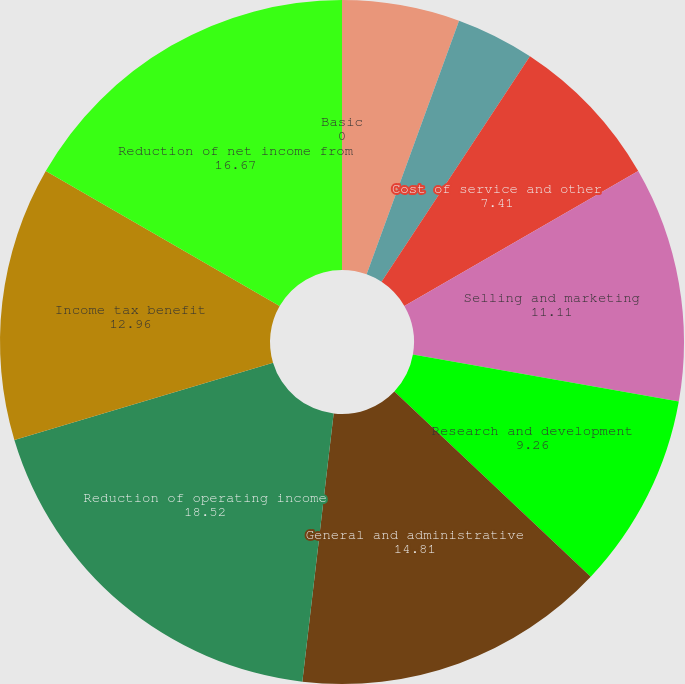Convert chart. <chart><loc_0><loc_0><loc_500><loc_500><pie_chart><fcel>(In thousands except per share<fcel>Cost of product revenue<fcel>Cost of service and other<fcel>Selling and marketing<fcel>Research and development<fcel>General and administrative<fcel>Reduction of operating income<fcel>Income tax benefit<fcel>Reduction of net income from<fcel>Basic<nl><fcel>5.56%<fcel>3.7%<fcel>7.41%<fcel>11.11%<fcel>9.26%<fcel>14.81%<fcel>18.52%<fcel>12.96%<fcel>16.67%<fcel>0.0%<nl></chart> 